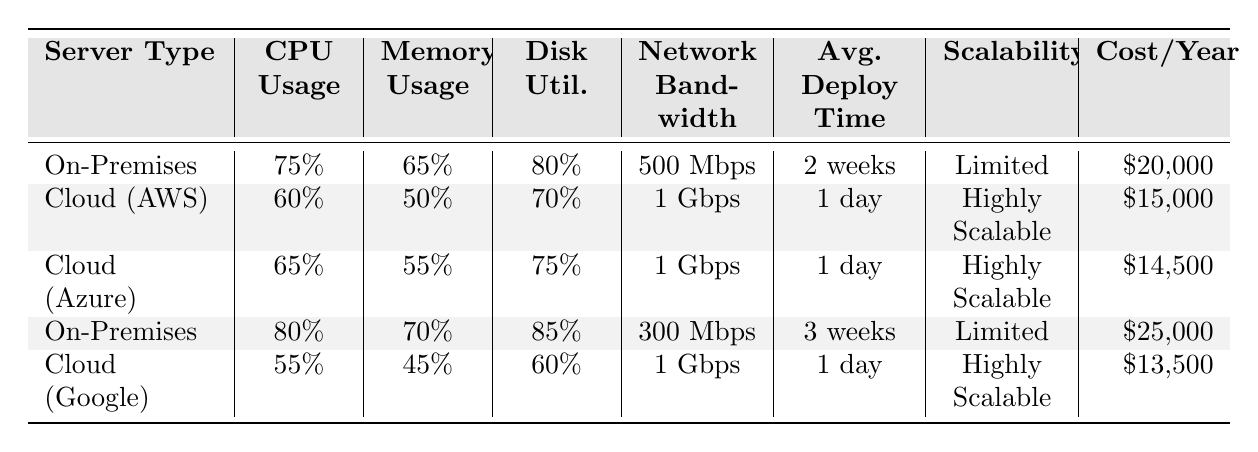What is the CPU usage of Cloud (Google)? The table shows that the CPU usage for Cloud (Google) is listed as 55%.
Answer: 55% Which server type has the highest network bandwidth? By comparing the network bandwidth values, Cloud (AWS), Cloud (Azure), and Cloud (Google) all have 1 Gbps, while On-Premises has lower values of 500 Mbps and 300 Mbps. Therefore, the highest network bandwidth, which is 1 Gbps, belongs to the cloud servers.
Answer: Cloud servers (AWS, Azure, Google) What is the average cost per year for On-Premises servers? There are two entries for On-Premises servers: $20,000 and $25,000. The average cost is calculated as (20000 + 25000) / 2 = 22500.
Answer: $22,500 Which server type has the lowest memory usage? Looking at the memory usage figures, Cloud (Google) has the lowest at 45%, compared to other server types.
Answer: Cloud (Google) Is the average deployment time for Cloud servers less than for On-Premises servers? The average deployment time for On-Premises servers is 2.5 weeks (average of 2 and 3 weeks), while the average deployment time for Cloud servers is 1 day. Since 1 day is less than 2.5 weeks, the statement is true.
Answer: Yes What is the total disk utilization for all Cloud servers combined? The disk utilization for Cloud (AWS) is 70%, Cloud (Azure) is 75%, and Cloud (Google) is 60%. Adding these values together gives 70 + 75 + 60 = 205%.
Answer: 205% What percentage of CPU usage do On-Premises servers exhibit on average? The CPU usage for On-Premises is 75% and 80%. To find the average, calculate (75 + 80) / 2 = 77.5%.
Answer: 77.5% Which server type is categorized as highly scalable? By reviewing the table, Cloud (AWS), Cloud (Azure), and Cloud (Google) are all described as highly scalable, while both On-Premises entries show limited scalability.
Answer: Cloud servers (AWS, Azure, Google) Is the cost per year higher for On-Premises or Cloud servers? Comparing the costs, On-Premises has costs of $20,000 and $25,000 while Cloud servers range from $13,500 to $15,000. Since both On-Premises figures are higher, the answer is On-Premises servers.
Answer: On-Premises servers What is the difference in average deployment time between On-Premises and Cloud servers? The average deployment time for On-Premises servers is 2.5 weeks, and for Cloud servers, it’s 1 day. Converting 1 day to weeks gives 1/7 weeks ≈ 0.14 weeks. The difference is 2.5 - 0.14 ≈ 2.36 weeks.
Answer: Approximately 2.36 weeks 